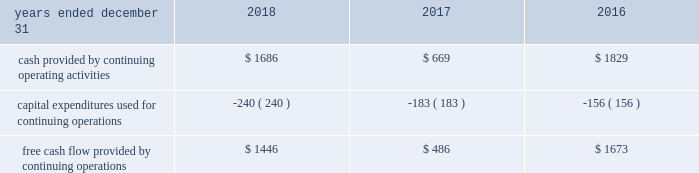( 1 ) adjusted other income ( expense ) excludes pension settlement charges of $ 37 million , $ 128 million , and $ 220 million , for the years ended 2018 , 2017 , and 2016 , respectively .
( 2 ) adjusted items are generally taxed at the estimated annual effective tax rate , except for the applicable tax impact associated with estimated restructuring plan expenses , legacy litigation , accelerated tradename amortization , impairment charges and non-cash pension settlement charges , which are adjusted at the related jurisdictional rates .
In addition , tax expense excludes the tax impacts from the sale of certain assets and liabilities previously classified as held for sale as well as the tax adjustments recorded to finalize the 2017 accounting for the enactment date impact of the tax reform act recorded pursuant torr sab 118 .
( 3 ) adjusted net income from discontinued operations excludes the gain on sale of discontinued operations of $ 82 million , $ 779 million , and $ 0 million for the years ended 2018 , 2017 , and 2016 , respectively .
Adjusted net income from discontinued operations excludes intangible asset amortization of $ 0 million , $ 11rr million , and $ 120 million for the twelve months ended december 31 , 2018 , 2017 , and 2016 , respectively .
The effective tax rate was further adjusted for the applicable tax impact associated with the gain on sale and intangible asset amortization , as applicable .
Free cash flow we use free cash flow , defined as cash flow provided by operations minus capital expenditures , as a non-gaap measure of our core operating performance and cash generating capabilities of our business operations .
This supplemental information related to free cash flow represents a measure not in accordance with u.s .
Gaap and should be viewed in addition to , not instead of , our financial statements .
The use of this non-gaap measure does not imply or represent the residual cash flow for discretionary expenditures .
A reconciliation of this non-gaap measure to cash flow provided by operations is as follows ( in millions ) : .
Impact of foreign currency exchange rate fluctuations we conduct business in more than 120 countries and sovereignties and , because of this , foreign currency exchange rate fluctuations have a significant impact on our business .
Foreign currency exchange rate movements may be significant and may distort true period-to-period comparisons of changes in revenue or pretax income .
Therefore , to give financial statement users meaningful information about our operations , we have provided an illustration of the impact of foreign currency exchange rate fluctuations on our financial results .
The methodology used to calculate this impact isolates the impact of the change in currencies between periods by translating the prior year 2019s revenue , expenses , and net income using the current year 2019s foreign currency exchange rates .
Translating prior year results at current year foreign currency exchange rates , currency fluctuations had a $ 0.08 favorable impact on net income per diluted share during the year ended december 31 , 2018 .
Currency fluctuations had a $ 0.12 favorable impact on net income per diluted share during the year ended december 31 , 2017 , when 2016 results were translated at 2017 rates .
Currency fluctuations had no impact on net income per diluted share during the year ended december 31 , 2016 , when 2015 results were translated at 2016 rates .
Translating prior year results at current year foreign currency exchange rates , currency fluctuations had a $ 0.09 favorable impact on adjusted net income per diluted share during the year ended december 31 , 2018 .
Currency fluctuations had a $ 0.08 favorable impact on adjusted net income per diluted share during the year ended december 31 , 2017 , when 2016 results were translated at 2017 rates .
Currency fluctuations had a $ 0.04 unfavorable impact on adjusted net income per diluted share during the year ended december 31 , 2016 , when 2015 results were translated at 2016 rates .
These translations are performed for comparative purposes only and do not impact the accounting policies or practices for amounts included in the financial statements .
Competition and markets authority the u.k . 2019s competition regulator , the competition and markets authority ( the 201ccma 201d ) , conducted a market investigation into the supply and acquisition of investment consulting and fiduciary management services , including those offered by aon and its competitors in the u.k. , to assess whether any feature or combination of features in the target market prevents , restricts , or distorts competition .
The cma issued a final report on december 12 , 2018 .
The cma will draft a series of orders that will set out the detailed remedies , expected in first quarter of 2019 , when they will be subject to further public consultation .
We do not anticipate the remedies to have a significant impact on the company 2019s consolidated financial position or business .
Financial conduct authority the fca is conducting a market study to assess how effectively competition is working in the wholesale insurance broker sector in the u.k .
In which aon , through its subsidiaries , participates .
The fca has indicated that the purpose of a market study is to assess the extent to which the market is working well in the interests of customers and to identify features of the market that may impact competition .
Depending on the study 2019s findings , the fca may require remedies in order to correct any features found .
Considering the years 2017 and 2018 , what is the percentual increase observed in capital expenditures used for continuing operations? 
Rationale: it is the 2018's capital expenditures value divided by the 2017's one , then transformed into a percentage .
Computations: ((240 / 183) - 1)
Answer: 0.31148. 